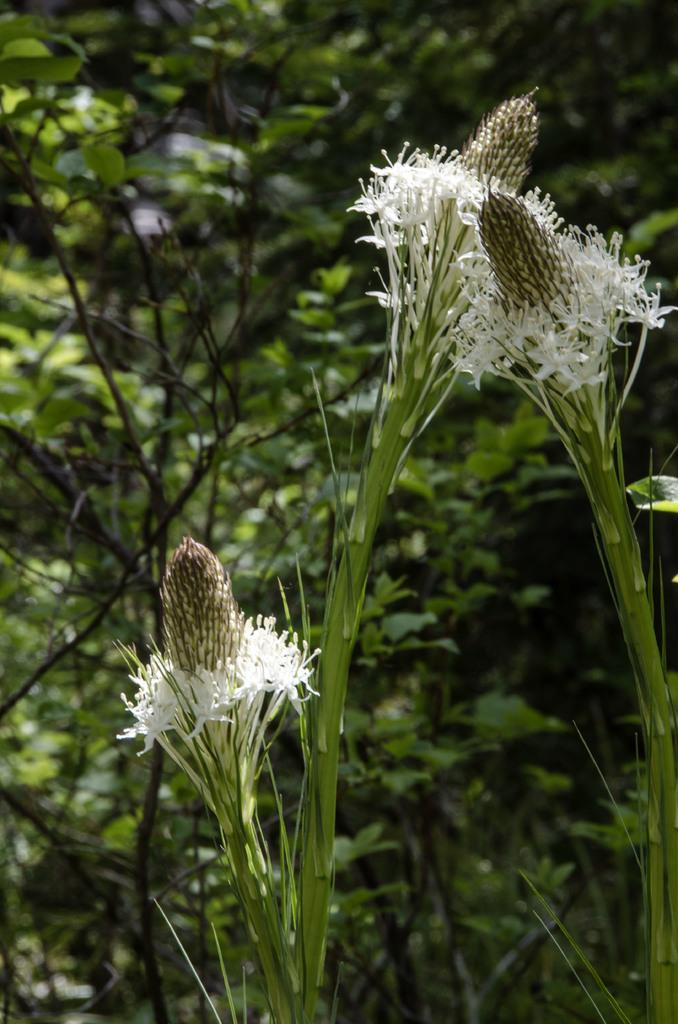What type of living organisms can be seen in the image? There are flowers in the image. How is the background of the image depicted? The background of the image is slightly blurred. What else can be seen in the background of the image? There are plants visible in the background of the image. What type of milk is being distributed to the flowers in the image? There is no milk or distribution process depicted in the image; it features flowers and plants in the background. 